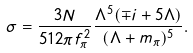Convert formula to latex. <formula><loc_0><loc_0><loc_500><loc_500>\sigma = \frac { 3 N } { 5 1 2 \pi f _ { \pi } ^ { 2 } } \frac { \Lambda ^ { 5 } ( \mp i + 5 \Lambda ) } { ( \Lambda + m _ { \pi } ) ^ { 5 } } .</formula> 